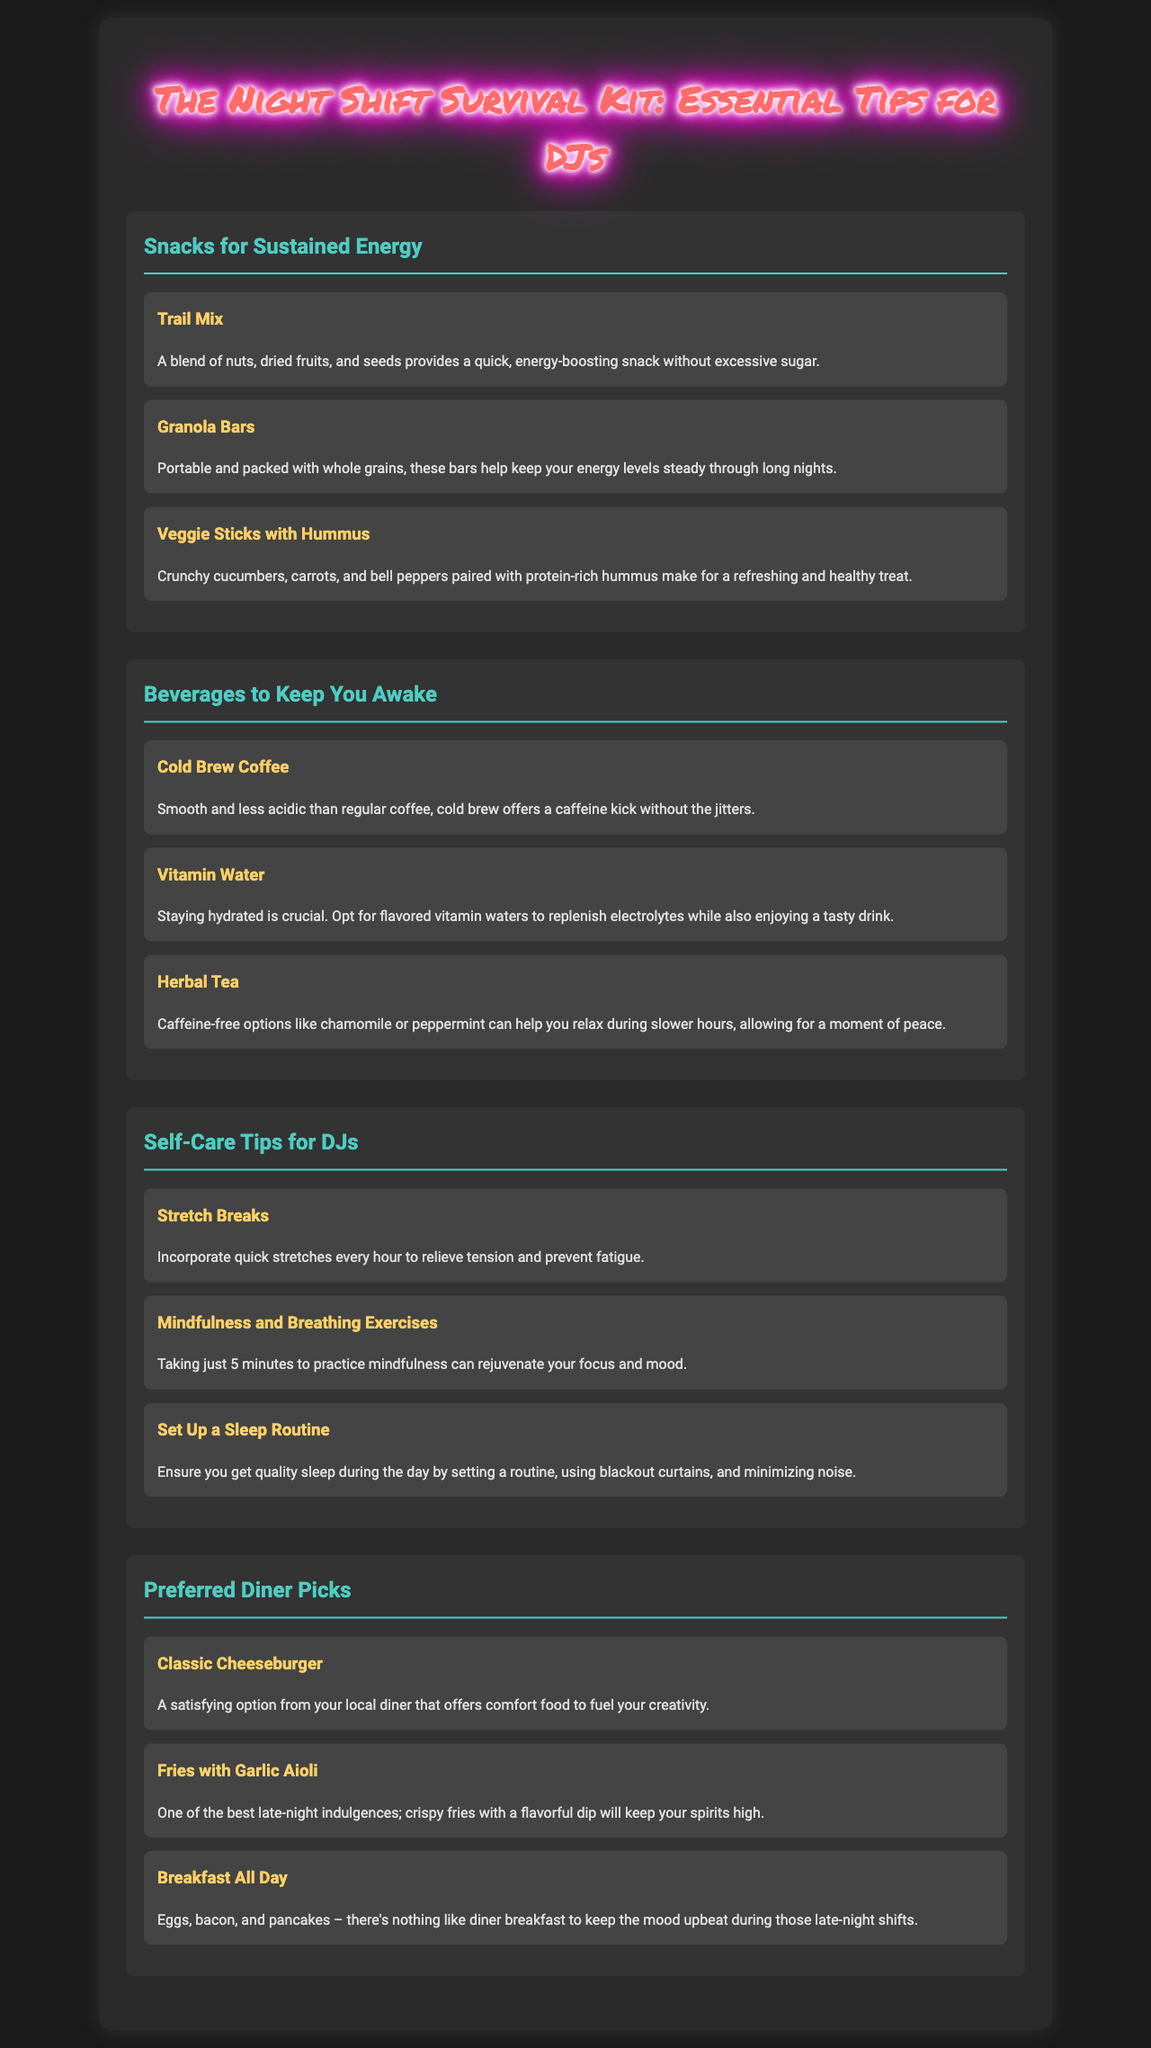what is the title of the document? The title of the document is clearly stated at the top of the brochure.
Answer: The Night Shift Survival Kit: Essential Tips for DJs which snack is mentioned as a refreshing and healthy treat? The document lists snacks and provides descriptions, one of which emphasizes healthiness.
Answer: Veggie Sticks with Hummus how many beverages are listed in the document? The document contains a section specifically dedicated to beverages, which consists of three items.
Answer: 3 what is one of the self-care tips suggested for DJs? The document includes several self-care tips for DJs, one of which is detailed in the section provided.
Answer: Stretch Breaks name a preferred diner pick that offers comfort food. The document identifies several items from preferred diner picks, highlighting one that satisfies hunger and comfort.
Answer: Classic Cheeseburger what is a key benefit of cold brew coffee mentioned in the brochure? The brochure provides a description of cold brew coffee, focusing on its advantages compared to regular coffee.
Answer: Caffeine kick without the jitters which snack is portable and packed with whole grains? The document describes different snacks, specifically indicating their portability and health aspects for DJs.
Answer: Granola Bars what exercise can help rejuvenate focus and mood? The document discusses mindfulness and breathing exercises as a self-care method, indicating its benefits.
Answer: Mindfulness and Breathing Exercises 